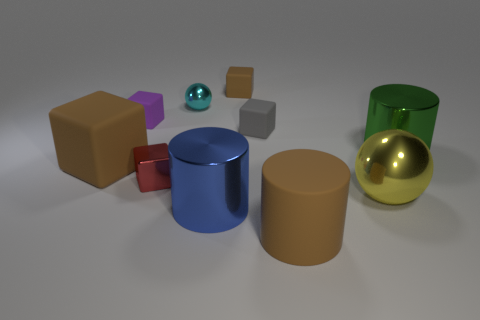Is the number of brown things less than the number of tiny yellow shiny spheres?
Give a very brief answer. No. Is there a brown matte thing that is in front of the brown object on the left side of the brown cube behind the big green metal thing?
Provide a succinct answer. Yes. There is a brown object left of the big blue cylinder; does it have the same shape as the blue object?
Your answer should be compact. No. Are there more green things that are in front of the purple matte thing than big red spheres?
Your response must be concise. Yes. There is a matte cube that is behind the small purple block; is it the same color as the big cube?
Your answer should be very brief. Yes. Are there any other things that have the same color as the big rubber cylinder?
Make the answer very short. Yes. What color is the large cylinder that is behind the small block that is in front of the shiny cylinder that is behind the large matte block?
Offer a terse response. Green. Does the green shiny cylinder have the same size as the gray cube?
Keep it short and to the point. No. How many brown metal blocks are the same size as the blue shiny cylinder?
Offer a very short reply. 0. What shape is the small rubber object that is the same color as the rubber cylinder?
Give a very brief answer. Cube. 